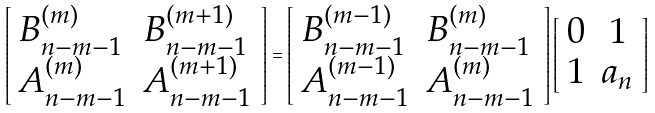<formula> <loc_0><loc_0><loc_500><loc_500>\left [ \begin{array} { l l } B ^ { ( m ) } _ { n - m - 1 } & B ^ { ( m + 1 ) } _ { n - m - 1 } \\ A ^ { ( m ) } _ { n - m - 1 } & A ^ { ( m + 1 ) } _ { n - m - 1 } \end{array} \right ] = \left [ \begin{array} { l l } B ^ { ( m - 1 ) } _ { n - m - 1 } & B ^ { ( m ) } _ { n - m - 1 } \\ A ^ { ( m - 1 ) } _ { n - m - 1 } & A ^ { ( m ) } _ { n - m - 1 } \end{array} \right ] \left [ \begin{array} { c c } 0 & 1 \\ 1 & a _ { n } \end{array} \right ]</formula> 